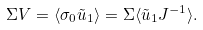Convert formula to latex. <formula><loc_0><loc_0><loc_500><loc_500>\Sigma V = \langle \sigma _ { 0 } \tilde { u } _ { 1 } \rangle = \Sigma \langle \tilde { u } _ { 1 } J ^ { - 1 } \rangle .</formula> 